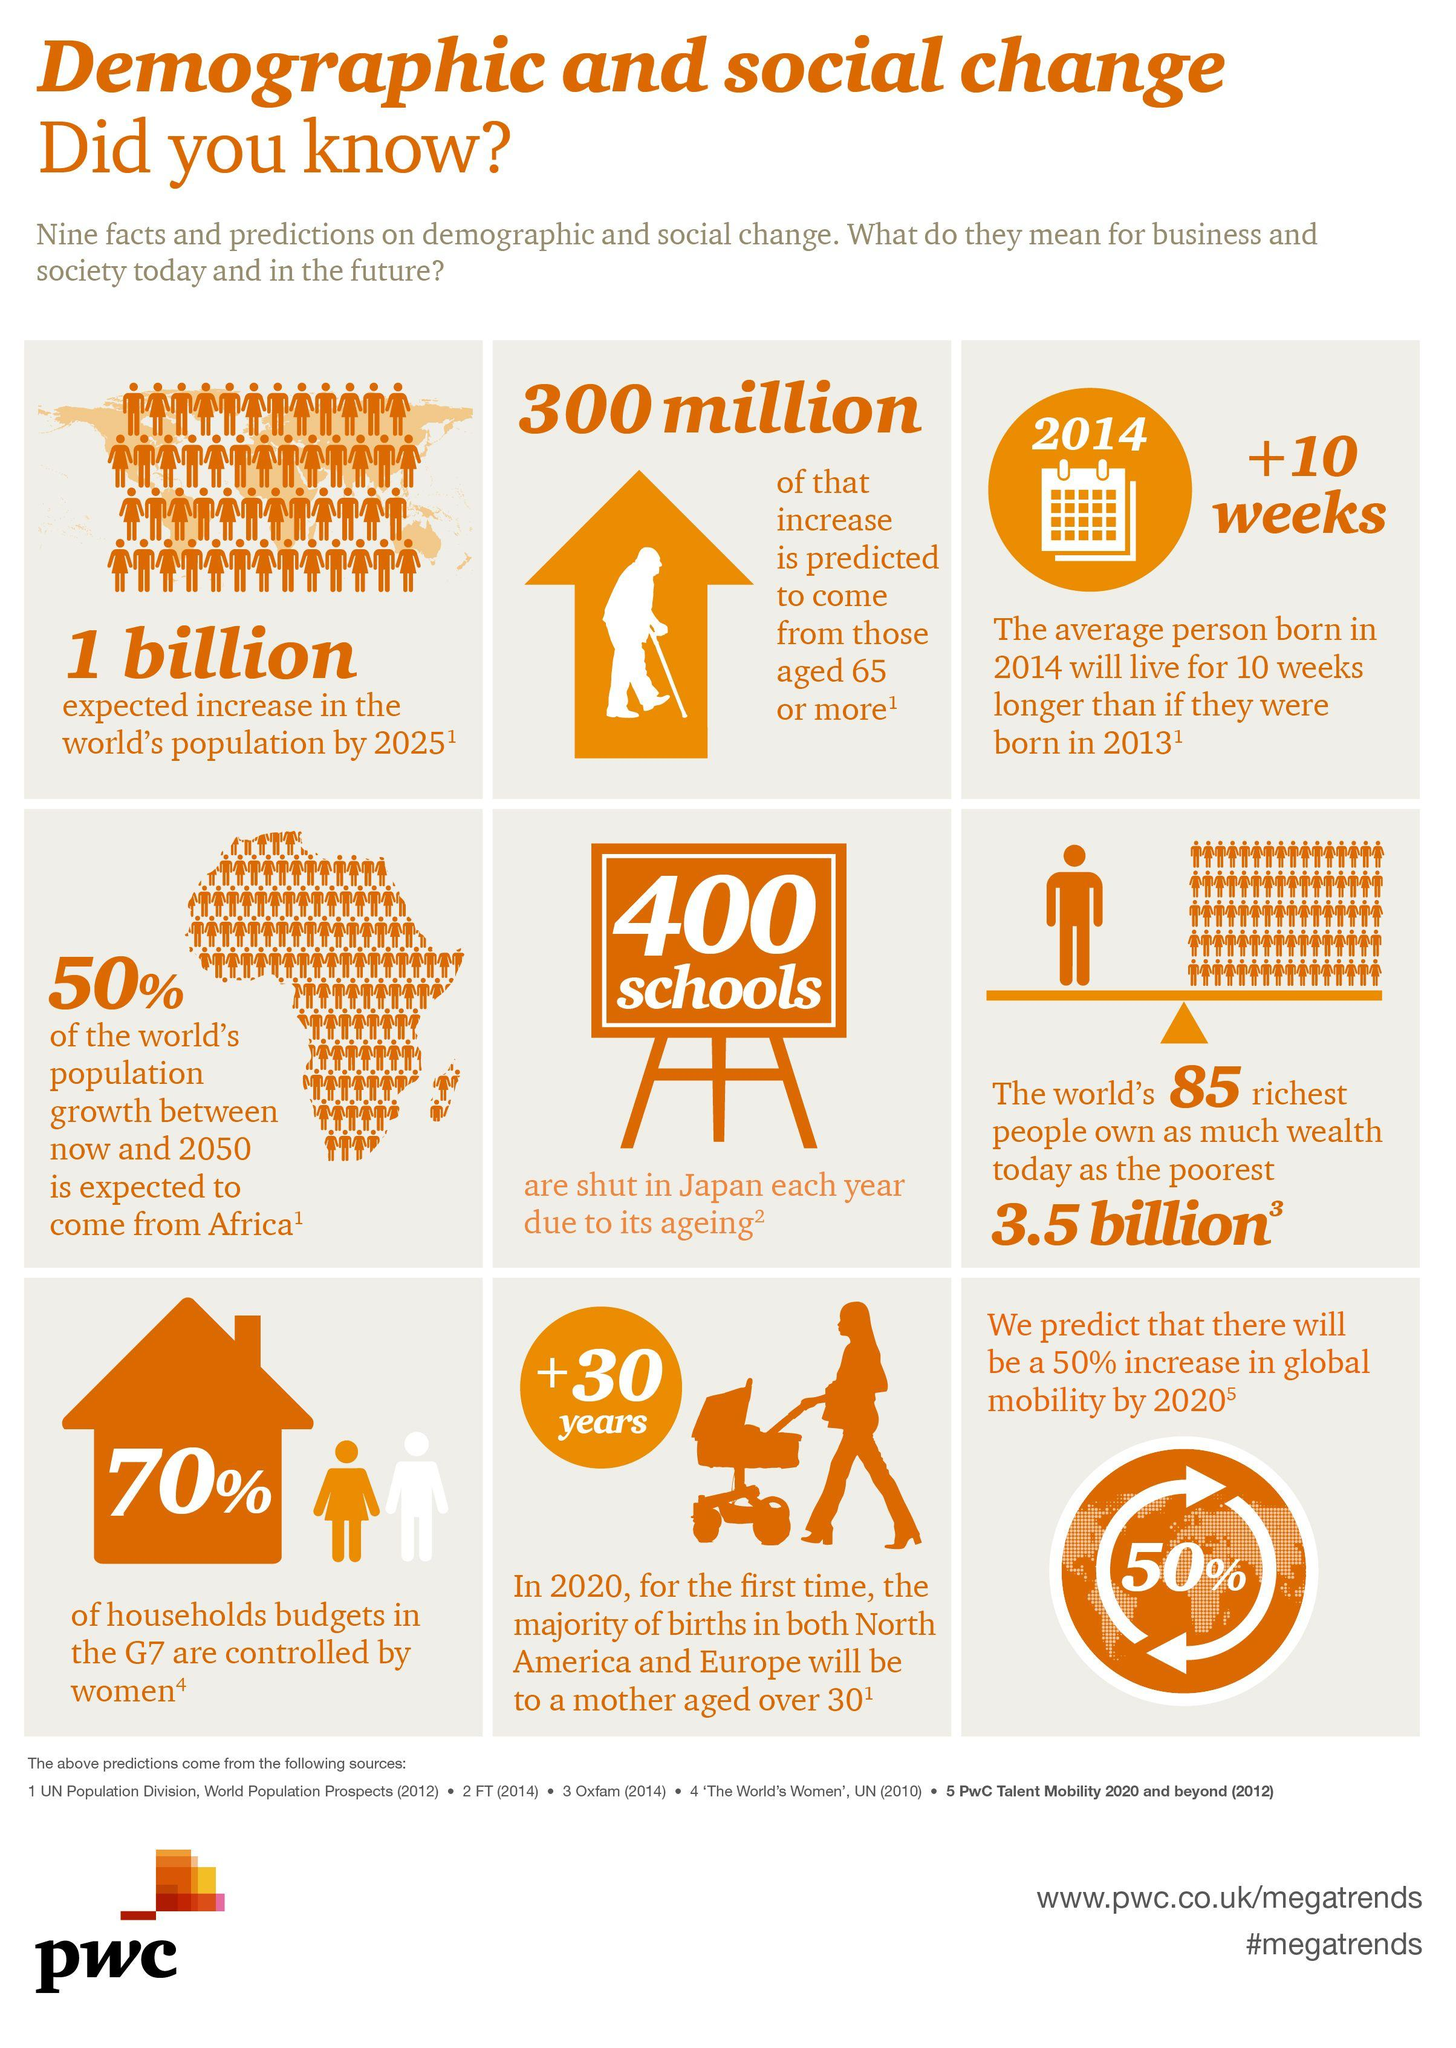Specify some key components in this picture. In the G7 countries, 30% of household budgets are not controlled by women, suggesting that women's economic empowerment is still a significant challenge in these nations. 